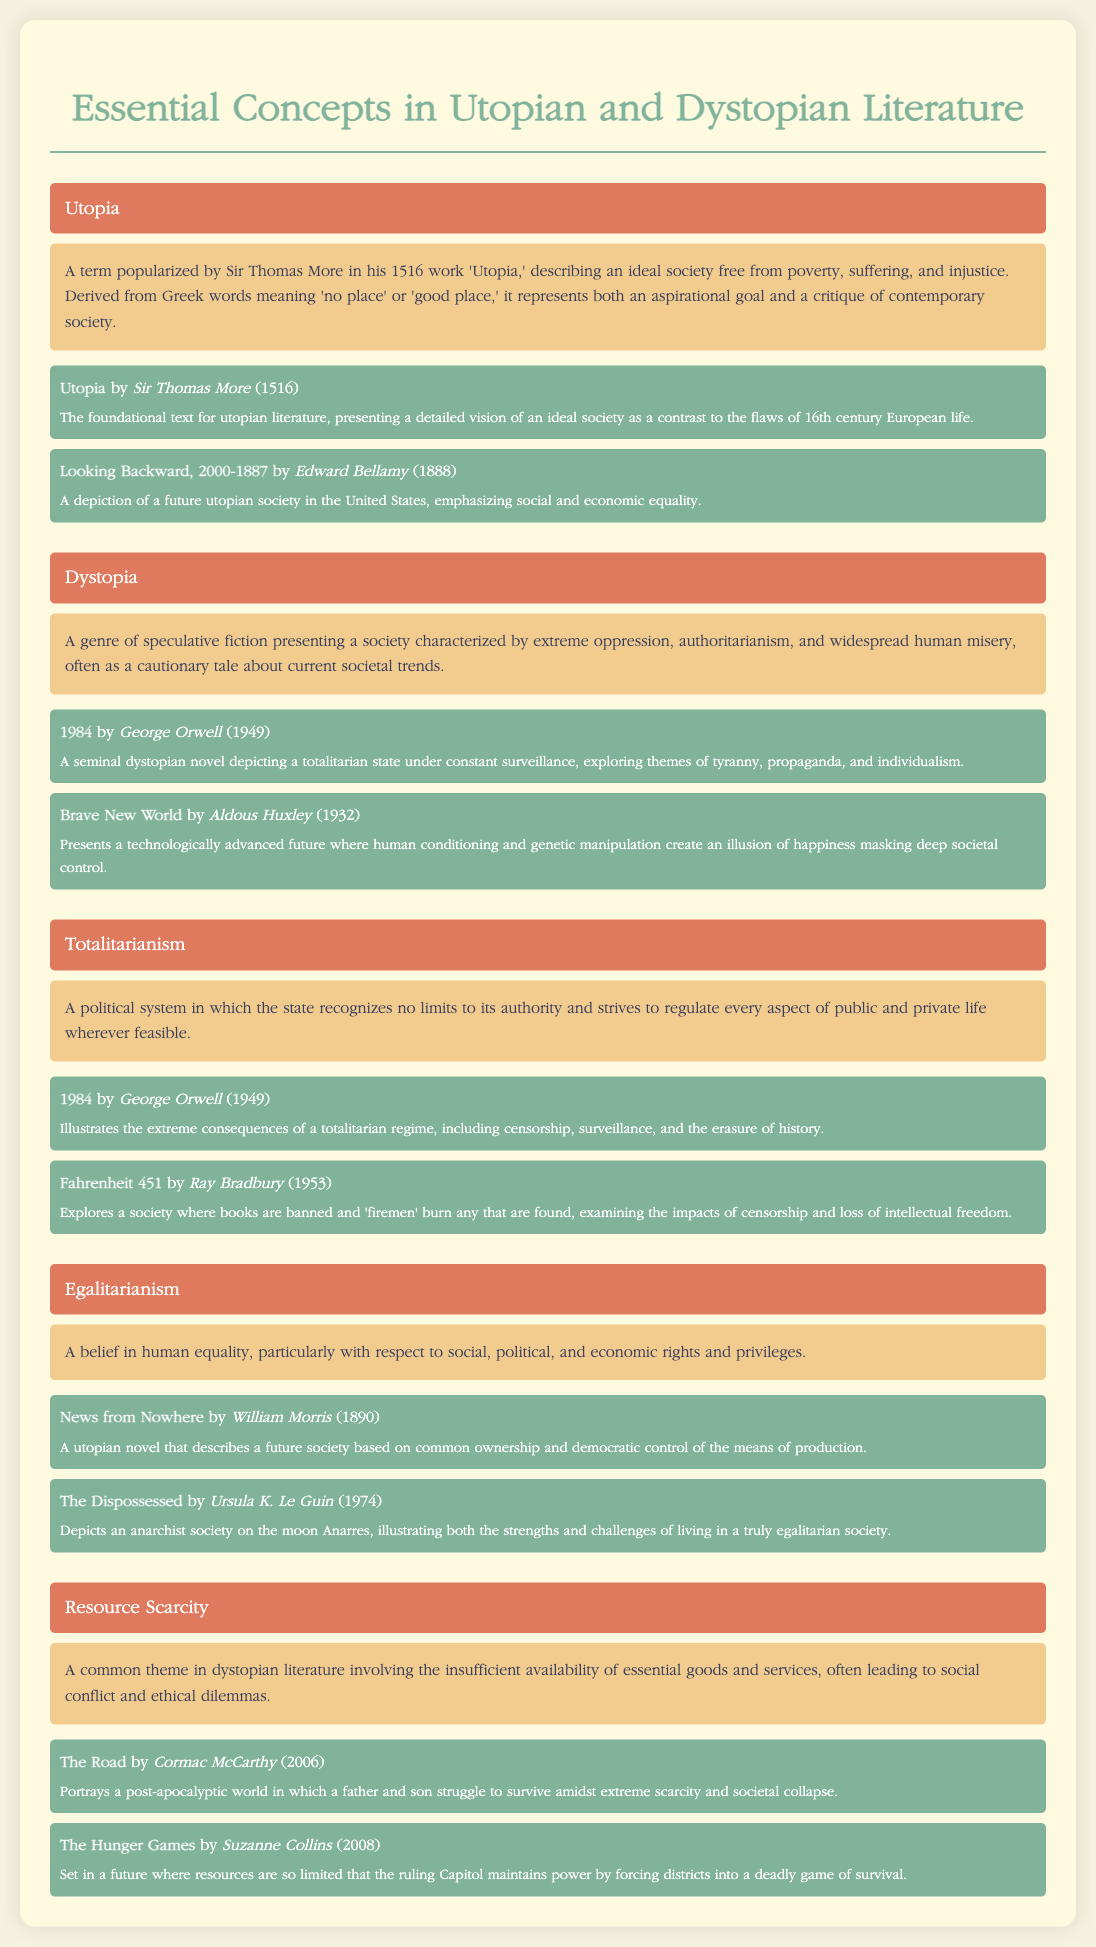What is the year of publication for 'Utopia'? 'Utopia' was published in 1516, as noted in the contextual literature section.
Answer: 1516 Who is the author of '1984'? '1984' is authored by George Orwell, as indicated in the book details for dystopian literature.
Answer: George Orwell What kind of political system does totalitarianism describe? Totalitarianism is described as a political system with no limits to state authority, which is found in the definition section.
Answer: No limits Which novel presents a future society emphasizing social and economic equality? 'Looking Backward, 2000-1887' is noted for depicting a future society focused on equality, as mentioned in the contextual literature section.
Answer: Looking Backward, 2000-1887 In which book do 'firemen' burn books? 'Fahrenheit 451' is the book that features firemen burning books, evident in the contextual literature section discussing totalitarianism.
Answer: Fahrenheit 451 How many significant novels are mentioned under 'Egalitarianism'? There are two significant novels mentioned under 'Egalitarianism' in the contextual literature.
Answer: Two What year was 'Brave New World' published? 'Brave New World' was published in 1932, which is specified in its contextual literature entry.
Answer: 1932 What concept does 'Resource Scarcity' relate to? 'Resource Scarcity' relates to the theme of insufficient availability of essential goods and services, as described in the definition section.
Answer: Insufficient availability Which author wrote 'The Hunger Games'? Suzanne Collins is the author of 'The Hunger Games,' as indicated in the contextual literature for resource scarcity.
Answer: Suzanne Collins 